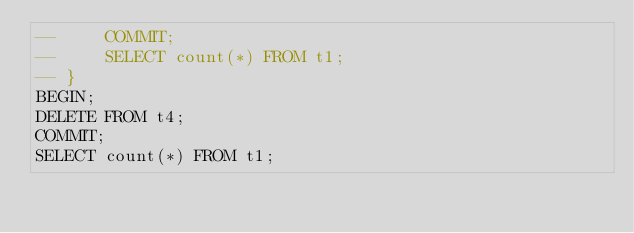<code> <loc_0><loc_0><loc_500><loc_500><_SQL_>--     COMMIT;
--     SELECT count(*) FROM t1;
-- }
BEGIN;
DELETE FROM t4;
COMMIT;
SELECT count(*) FROM t1;</code> 